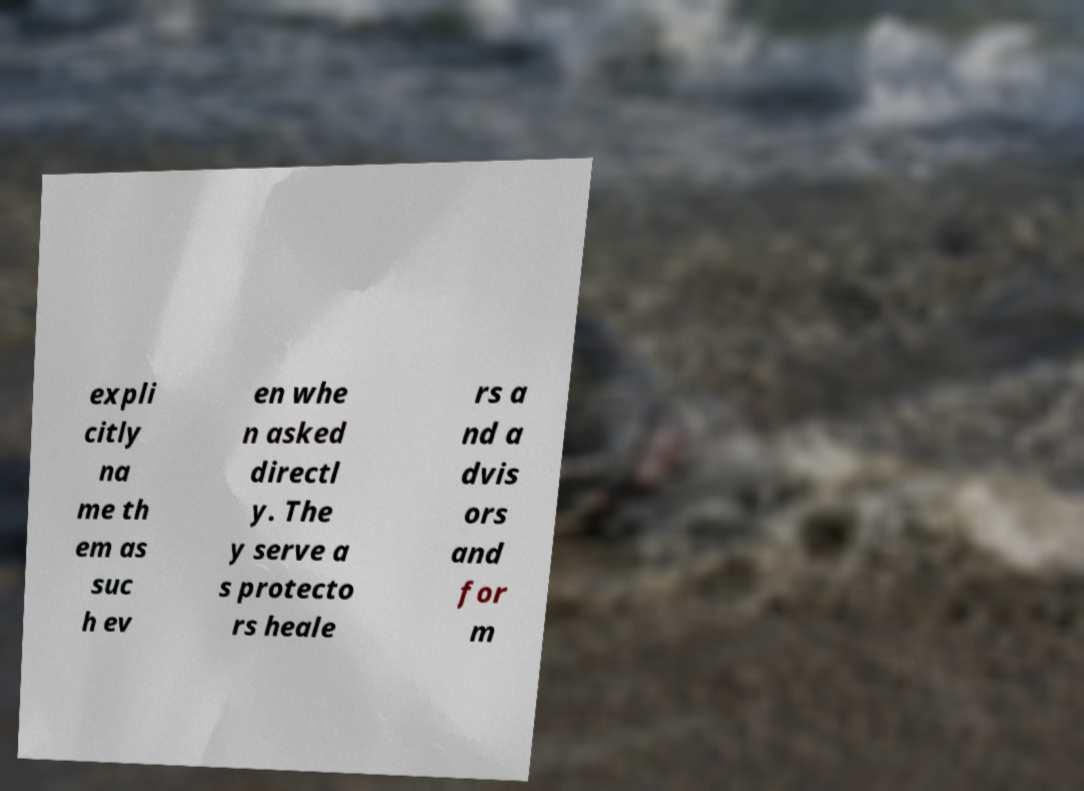Please read and relay the text visible in this image. What does it say? expli citly na me th em as suc h ev en whe n asked directl y. The y serve a s protecto rs heale rs a nd a dvis ors and for m 